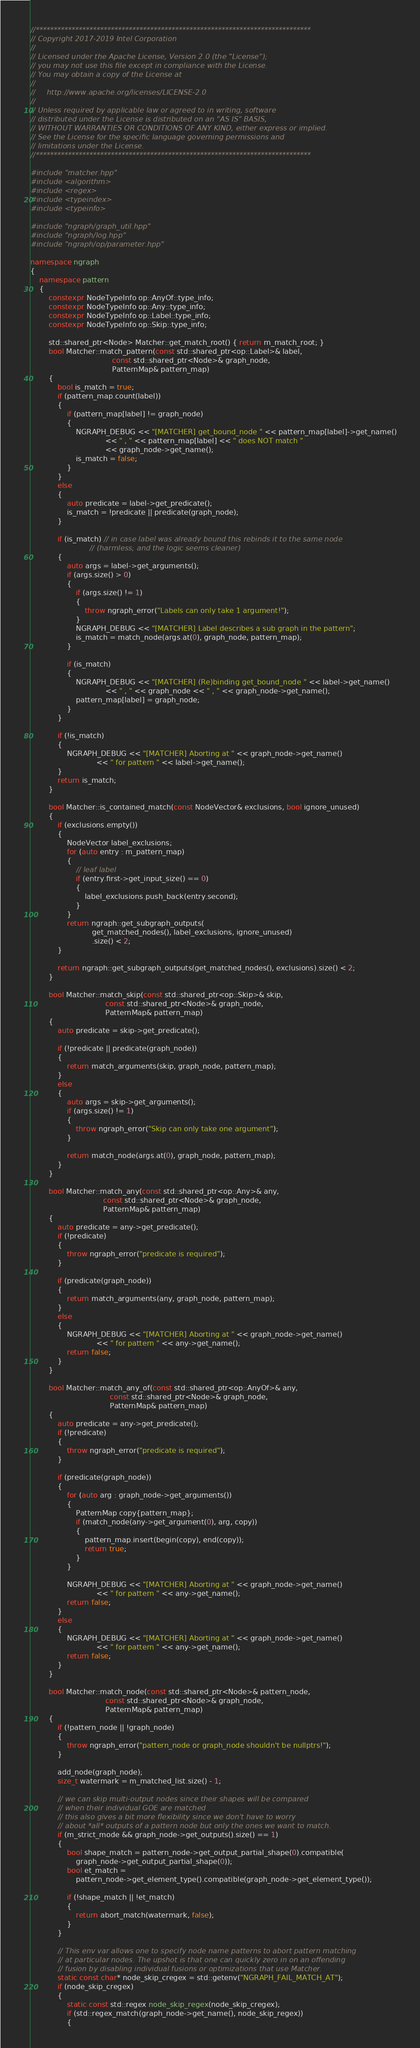<code> <loc_0><loc_0><loc_500><loc_500><_C++_>//*****************************************************************************
// Copyright 2017-2019 Intel Corporation
//
// Licensed under the Apache License, Version 2.0 (the "License");
// you may not use this file except in compliance with the License.
// You may obtain a copy of the License at
//
//     http://www.apache.org/licenses/LICENSE-2.0
//
// Unless required by applicable law or agreed to in writing, software
// distributed under the License is distributed on an "AS IS" BASIS,
// WITHOUT WARRANTIES OR CONDITIONS OF ANY KIND, either express or implied.
// See the License for the specific language governing permissions and
// limitations under the License.
//*****************************************************************************

#include "matcher.hpp"
#include <algorithm>
#include <regex>
#include <typeindex>
#include <typeinfo>

#include "ngraph/graph_util.hpp"
#include "ngraph/log.hpp"
#include "ngraph/op/parameter.hpp"

namespace ngraph
{
    namespace pattern
    {
        constexpr NodeTypeInfo op::AnyOf::type_info;
        constexpr NodeTypeInfo op::Any::type_info;
        constexpr NodeTypeInfo op::Label::type_info;
        constexpr NodeTypeInfo op::Skip::type_info;

        std::shared_ptr<Node> Matcher::get_match_root() { return m_match_root; }
        bool Matcher::match_pattern(const std::shared_ptr<op::Label>& label,
                                    const std::shared_ptr<Node>& graph_node,
                                    PatternMap& pattern_map)
        {
            bool is_match = true;
            if (pattern_map.count(label))
            {
                if (pattern_map[label] != graph_node)
                {
                    NGRAPH_DEBUG << "[MATCHER] get_bound_node " << pattern_map[label]->get_name()
                                 << " , " << pattern_map[label] << " does NOT match "
                                 << graph_node->get_name();
                    is_match = false;
                }
            }
            else
            {
                auto predicate = label->get_predicate();
                is_match = !predicate || predicate(graph_node);
            }

            if (is_match) // in case label was already bound this rebinds it to the same node
                          // (harmless; and the logic seems cleaner)
            {
                auto args = label->get_arguments();
                if (args.size() > 0)
                {
                    if (args.size() != 1)
                    {
                        throw ngraph_error("Labels can only take 1 argument!");
                    }
                    NGRAPH_DEBUG << "[MATCHER] Label describes a sub graph in the pattern";
                    is_match = match_node(args.at(0), graph_node, pattern_map);
                }

                if (is_match)
                {
                    NGRAPH_DEBUG << "[MATCHER] (Re)binding get_bound_node " << label->get_name()
                                 << " , " << graph_node << " , " << graph_node->get_name();
                    pattern_map[label] = graph_node;
                }
            }

            if (!is_match)
            {
                NGRAPH_DEBUG << "[MATCHER] Aborting at " << graph_node->get_name()
                             << " for pattern " << label->get_name();
            }
            return is_match;
        }

        bool Matcher::is_contained_match(const NodeVector& exclusions, bool ignore_unused)
        {
            if (exclusions.empty())
            {
                NodeVector label_exclusions;
                for (auto entry : m_pattern_map)
                {
                    // leaf label
                    if (entry.first->get_input_size() == 0)
                    {
                        label_exclusions.push_back(entry.second);
                    }
                }
                return ngraph::get_subgraph_outputs(
                           get_matched_nodes(), label_exclusions, ignore_unused)
                           .size() < 2;
            }

            return ngraph::get_subgraph_outputs(get_matched_nodes(), exclusions).size() < 2;
        }

        bool Matcher::match_skip(const std::shared_ptr<op::Skip>& skip,
                                 const std::shared_ptr<Node>& graph_node,
                                 PatternMap& pattern_map)
        {
            auto predicate = skip->get_predicate();

            if (!predicate || predicate(graph_node))
            {
                return match_arguments(skip, graph_node, pattern_map);
            }
            else
            {
                auto args = skip->get_arguments();
                if (args.size() != 1)
                {
                    throw ngraph_error("Skip can only take one argument");
                }

                return match_node(args.at(0), graph_node, pattern_map);
            }
        }

        bool Matcher::match_any(const std::shared_ptr<op::Any>& any,
                                const std::shared_ptr<Node>& graph_node,
                                PatternMap& pattern_map)
        {
            auto predicate = any->get_predicate();
            if (!predicate)
            {
                throw ngraph_error("predicate is required");
            }

            if (predicate(graph_node))
            {
                return match_arguments(any, graph_node, pattern_map);
            }
            else
            {
                NGRAPH_DEBUG << "[MATCHER] Aborting at " << graph_node->get_name()
                             << " for pattern " << any->get_name();
                return false;
            }
        }

        bool Matcher::match_any_of(const std::shared_ptr<op::AnyOf>& any,
                                   const std::shared_ptr<Node>& graph_node,
                                   PatternMap& pattern_map)
        {
            auto predicate = any->get_predicate();
            if (!predicate)
            {
                throw ngraph_error("predicate is required");
            }

            if (predicate(graph_node))
            {
                for (auto arg : graph_node->get_arguments())
                {
                    PatternMap copy{pattern_map};
                    if (match_node(any->get_argument(0), arg, copy))
                    {
                        pattern_map.insert(begin(copy), end(copy));
                        return true;
                    }
                }

                NGRAPH_DEBUG << "[MATCHER] Aborting at " << graph_node->get_name()
                             << " for pattern " << any->get_name();
                return false;
            }
            else
            {
                NGRAPH_DEBUG << "[MATCHER] Aborting at " << graph_node->get_name()
                             << " for pattern " << any->get_name();
                return false;
            }
        }

        bool Matcher::match_node(const std::shared_ptr<Node>& pattern_node,
                                 const std::shared_ptr<Node>& graph_node,
                                 PatternMap& pattern_map)
        {
            if (!pattern_node || !graph_node)
            {
                throw ngraph_error("pattern_node or graph_node shouldn't be nullptrs!");
            }

            add_node(graph_node);
            size_t watermark = m_matched_list.size() - 1;

            // we can skip multi-output nodes since their shapes will be compared
            // when their individual GOE are matched
            // this also gives a bit more flexibility since we don't have to worry
            // about *all* outputs of a pattern node but only the ones we want to match.
            if (m_strict_mode && graph_node->get_outputs().size() == 1)
            {
                bool shape_match = pattern_node->get_output_partial_shape(0).compatible(
                    graph_node->get_output_partial_shape(0));
                bool et_match =
                    pattern_node->get_element_type().compatible(graph_node->get_element_type());

                if (!shape_match || !et_match)
                {
                    return abort_match(watermark, false);
                }
            }

            // This env var allows one to specify node name patterns to abort pattern matching
            // at particular nodes. The upshot is that one can quickly zero in on an offending
            // fusion by disabling individual fusions or optimizations that use Matcher.
            static const char* node_skip_cregex = std::getenv("NGRAPH_FAIL_MATCH_AT");
            if (node_skip_cregex)
            {
                static const std::regex node_skip_regex(node_skip_cregex);
                if (std::regex_match(graph_node->get_name(), node_skip_regex))
                {</code> 